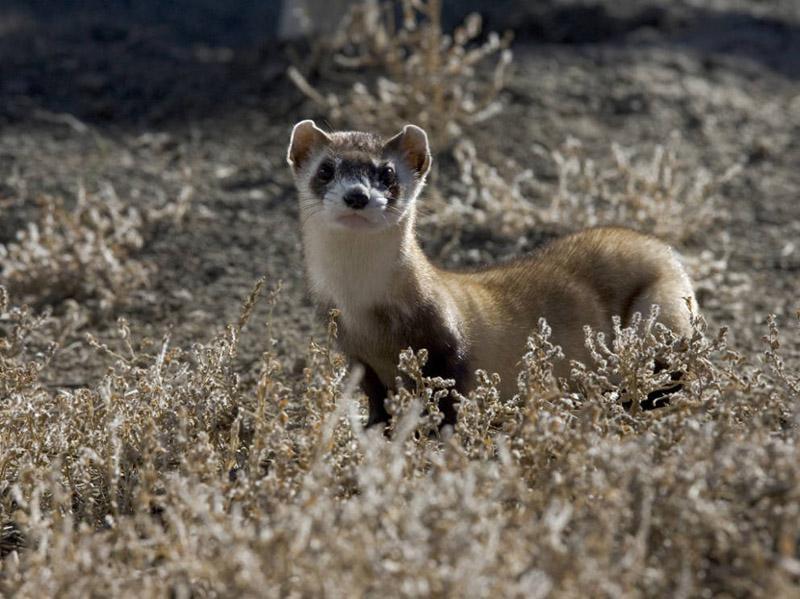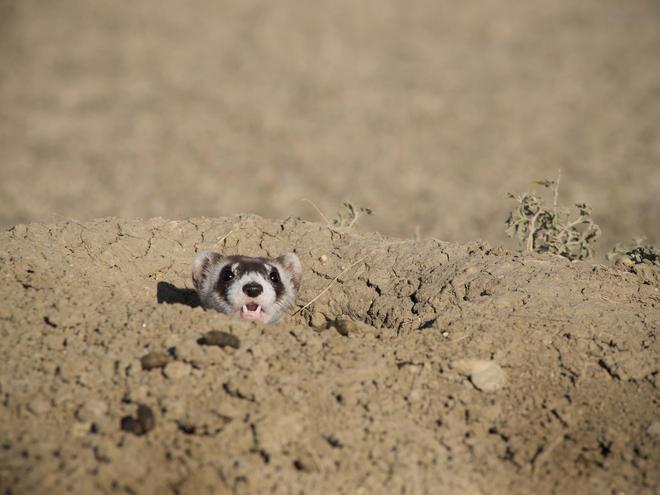The first image is the image on the left, the second image is the image on the right. Evaluate the accuracy of this statement regarding the images: "One animal is in a hole, one animal is not, and there is not a third animal.". Is it true? Answer yes or no. Yes. 